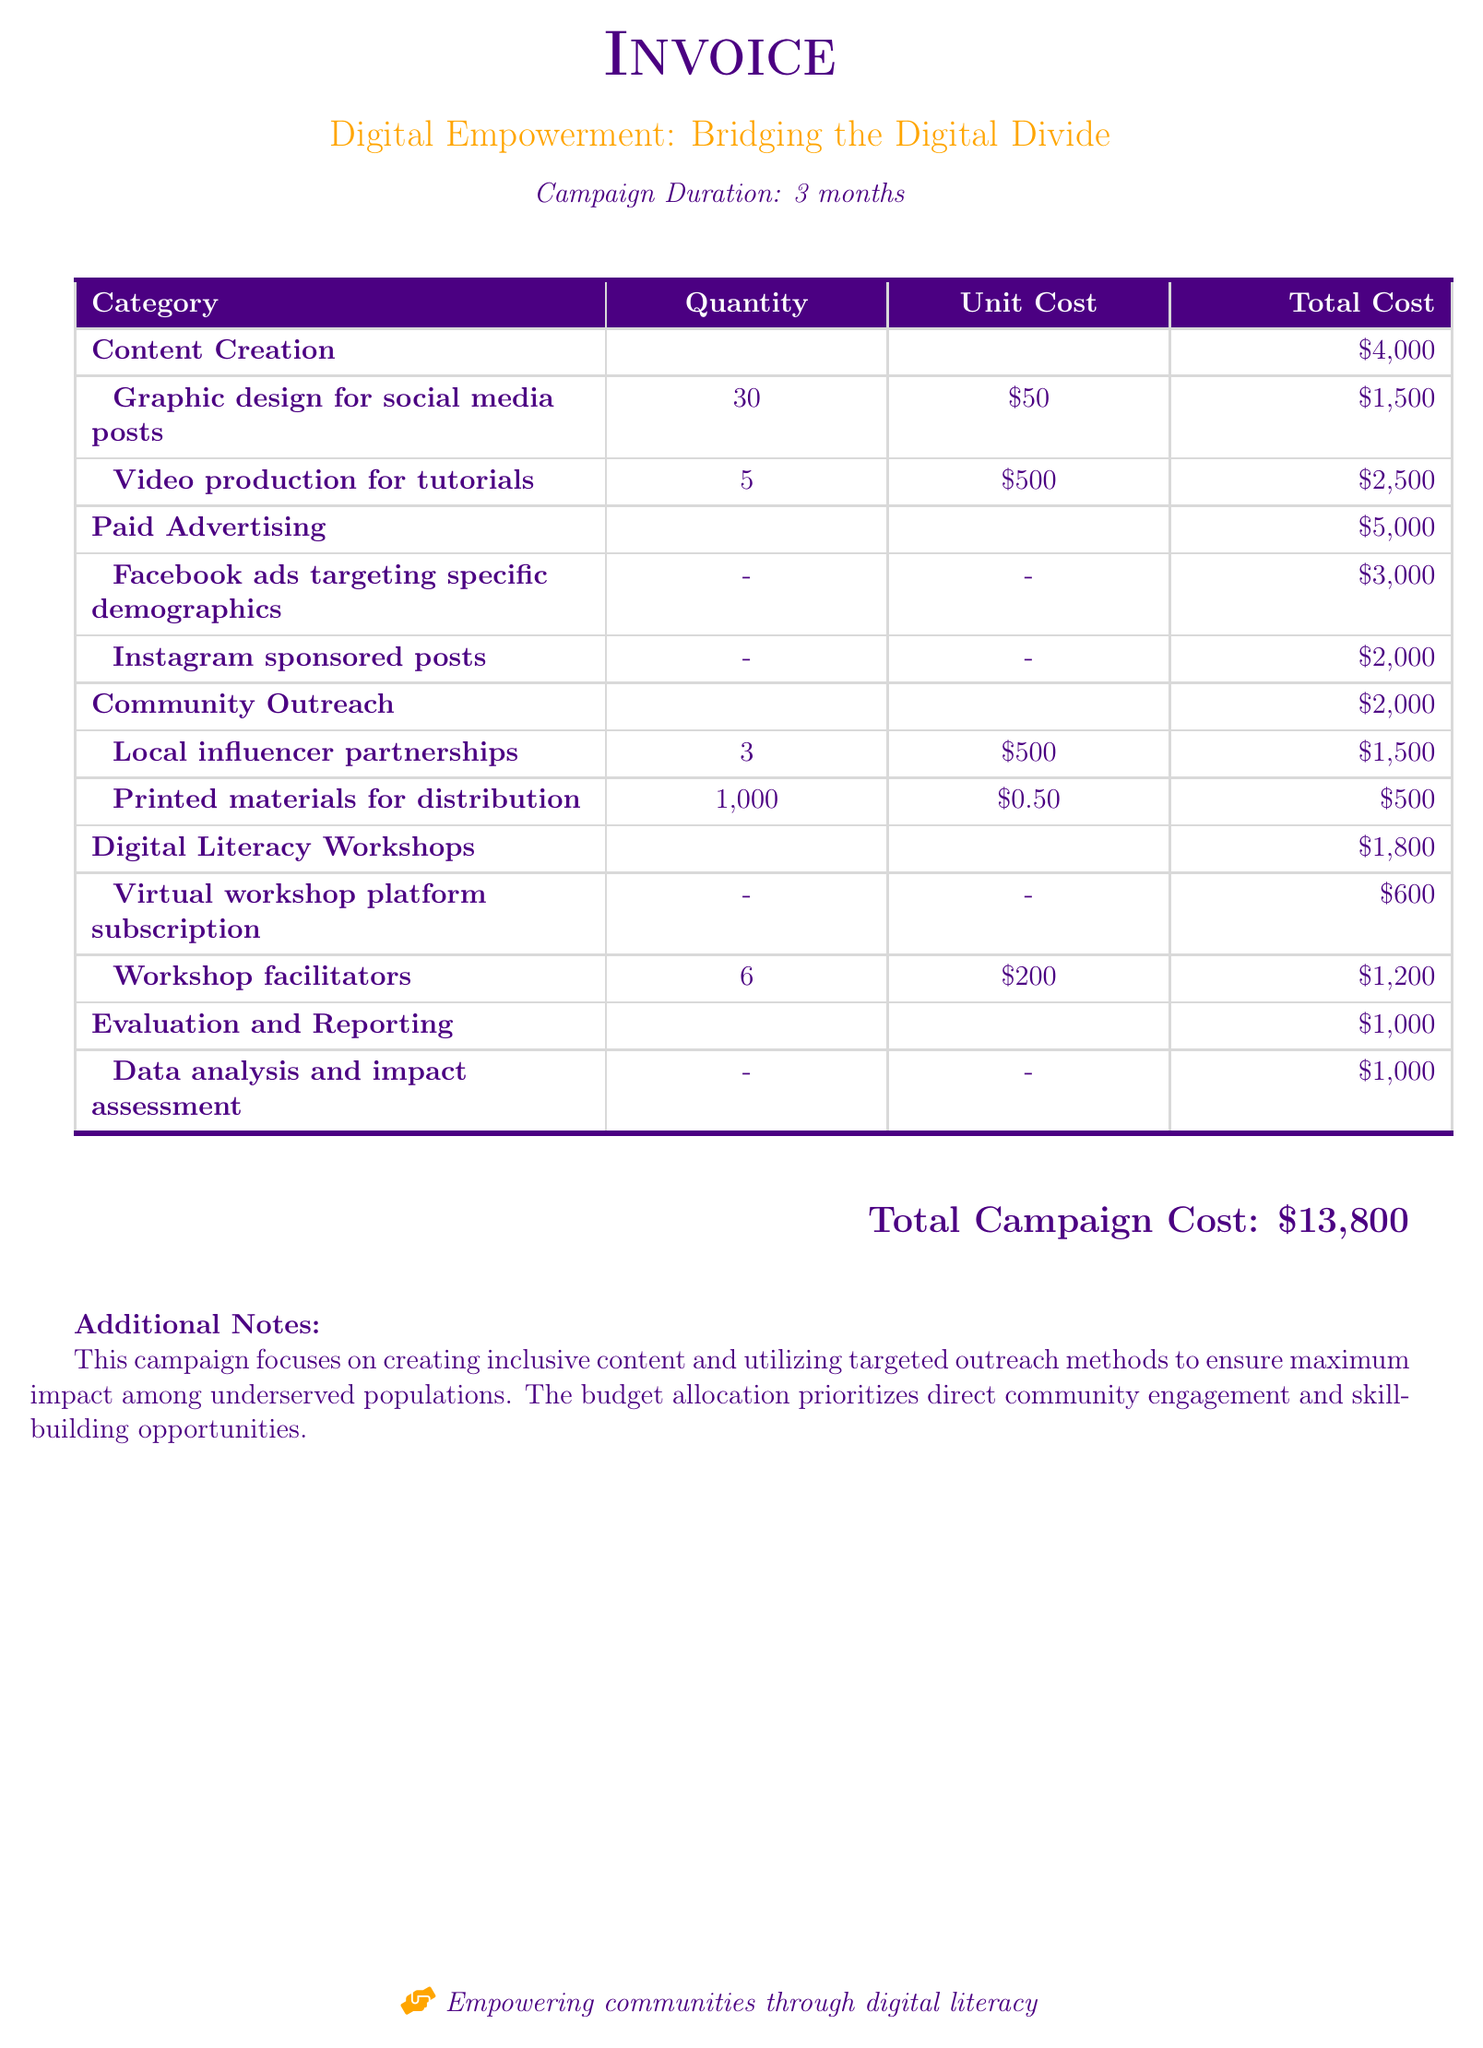What is the total campaign cost? The total campaign cost is listed at the bottom of the document, which totals all expenses incurred during the campaign.
Answer: $13,800 How long is the campaign duration? The campaign duration is specified in the header section of the document as a timeframe for the proposed initiatives.
Answer: 3 months What is allocated for paid advertising? This category specifies the budget set aside for ads, differentiating between various platforms for outreach.
Answer: $5,000 How many graphic designs are created for social media posts? The quantity for graphic designs is explicitly stated in the content creation section of the document under graphic design.
Answer: 30 What is the cost of the printed materials for distribution? This cost is detailed under the community outreach category, showing how funds are allocated for these materials.
Answer: $500 What is the role of community outreach in the campaign? Community outreach aims to engage directly with underserved populations, which can be inferred from the associated costs and activities listed in the document.
Answer: $2,000 How many virtual workshop platform subscriptions are included? The number related to this specific item is noted in the digital literacy workshops section, indicating how many subscriptions will be acquired.
Answer: - What is the expense for data analysis and impact assessment? The document specifies the allocation for this evaluation process, which is important for understanding the campaign's effectiveness.
Answer: $1,000 What type of workshops are planned in this campaign? The document outlines that specific workshops are intended to enhance the skills of the target audiences, thus emphasizing a particular theme of empowerment.
Answer: Digital Literacy Workshops 